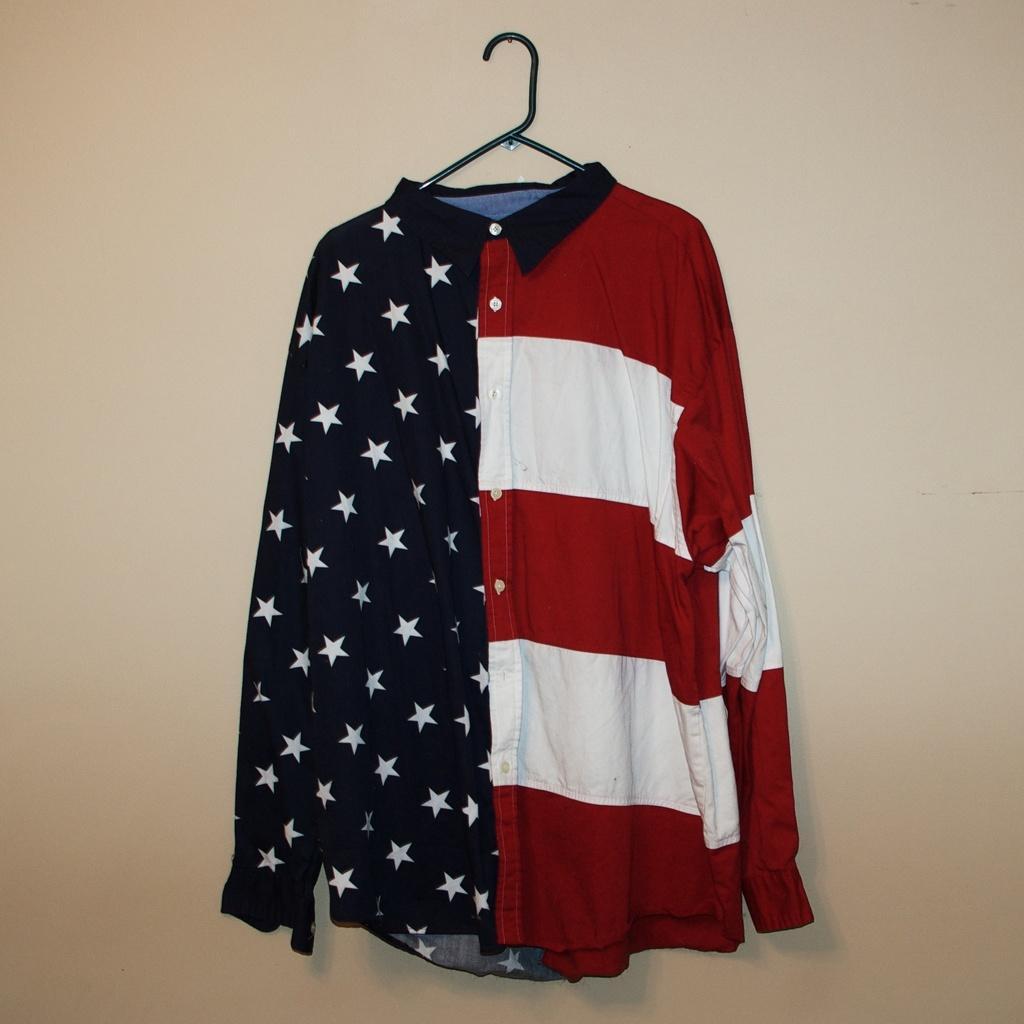Describe this image in one or two sentences. In this image, at the middle we can see a shirt which is in white, red and black color hanging in the hanger, there is a cream color wall. 